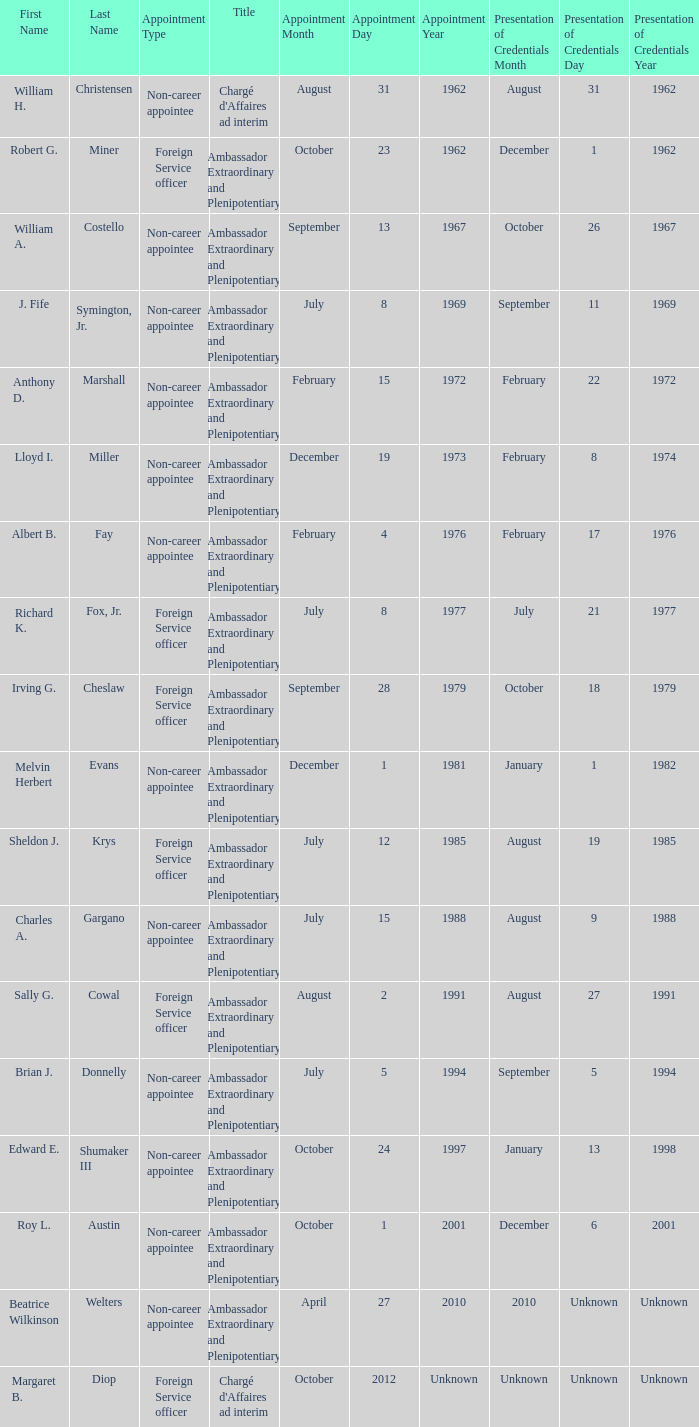Who was appointed on October 24, 1997? Edward E. Shumaker III. 